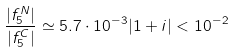Convert formula to latex. <formula><loc_0><loc_0><loc_500><loc_500>\frac { | f ^ { N } _ { 5 } | } { | f ^ { C } _ { 5 } | } \simeq 5 . 7 \cdot 1 0 ^ { - 3 } | 1 + i | < 1 0 ^ { - 2 }</formula> 